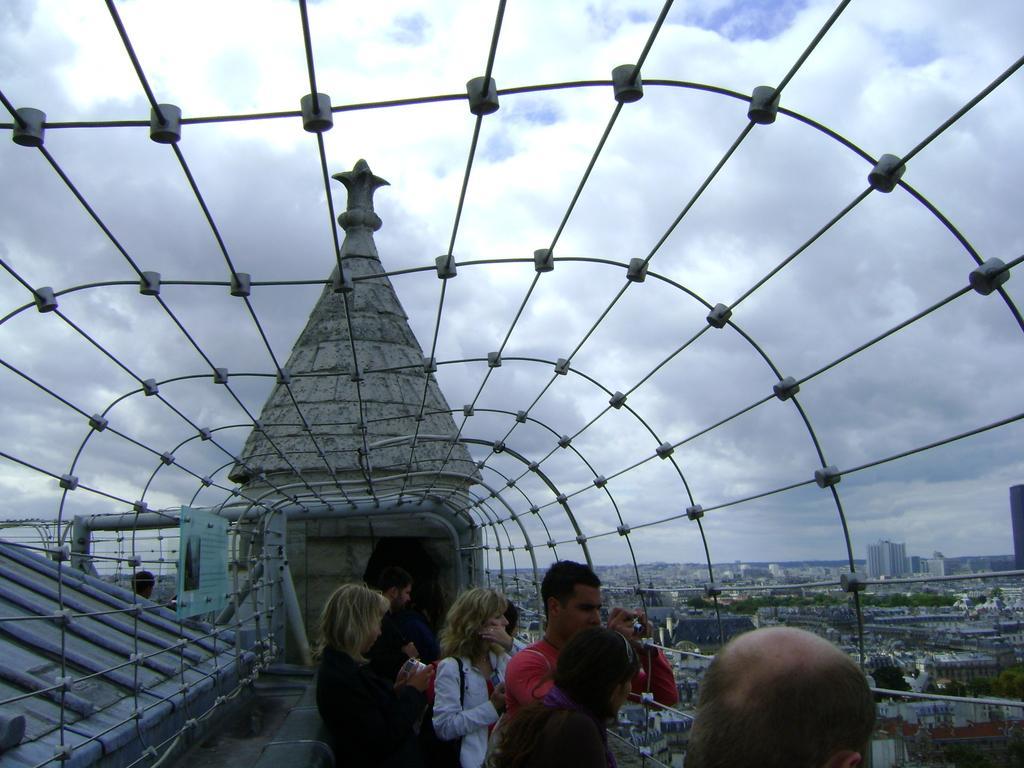Can you describe this image briefly? At the bottom of the image few people are standing and watching. Behind them there is fencing and there are some trees and buildings. At the top of the image there are some clouds and sky. 